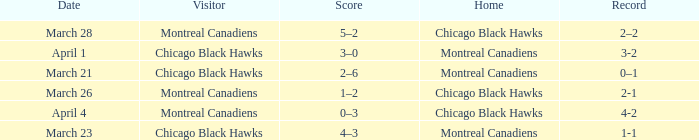What is the score for the team with a record of 2-1? 1–2. 